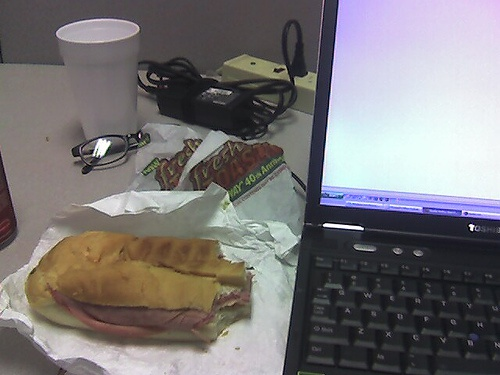Describe the objects in this image and their specific colors. I can see laptop in black, lavender, and violet tones, sandwich in black, brown, olive, and gray tones, and cup in black, gray, darkgray, and lightgray tones in this image. 